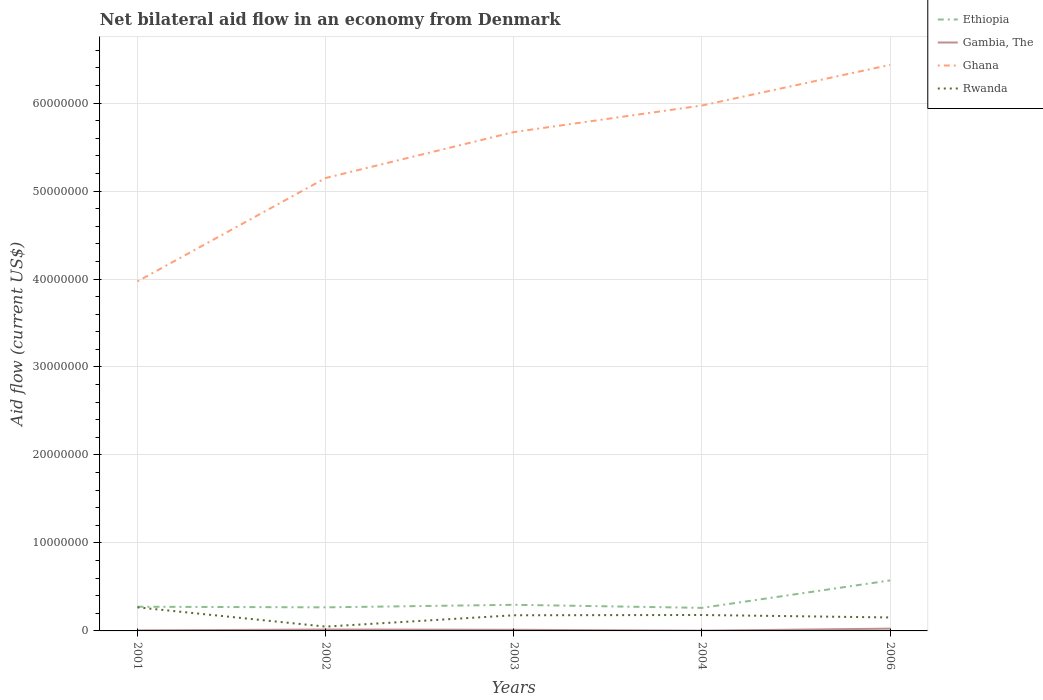Is the number of lines equal to the number of legend labels?
Offer a terse response. Yes. What is the total net bilateral aid flow in Gambia, The in the graph?
Provide a short and direct response. 1.30e+05. What is the difference between the highest and the second highest net bilateral aid flow in Ethiopia?
Offer a terse response. 3.12e+06. How many years are there in the graph?
Give a very brief answer. 5. Are the values on the major ticks of Y-axis written in scientific E-notation?
Offer a terse response. No. Does the graph contain any zero values?
Give a very brief answer. No. How many legend labels are there?
Your response must be concise. 4. What is the title of the graph?
Ensure brevity in your answer.  Net bilateral aid flow in an economy from Denmark. Does "Hong Kong" appear as one of the legend labels in the graph?
Your answer should be very brief. No. What is the label or title of the Y-axis?
Provide a succinct answer. Aid flow (current US$). What is the Aid flow (current US$) of Ethiopia in 2001?
Your response must be concise. 2.75e+06. What is the Aid flow (current US$) in Gambia, The in 2001?
Keep it short and to the point. 6.00e+04. What is the Aid flow (current US$) of Ghana in 2001?
Ensure brevity in your answer.  3.97e+07. What is the Aid flow (current US$) in Rwanda in 2001?
Your answer should be compact. 2.68e+06. What is the Aid flow (current US$) in Ethiopia in 2002?
Give a very brief answer. 2.68e+06. What is the Aid flow (current US$) of Ghana in 2002?
Give a very brief answer. 5.15e+07. What is the Aid flow (current US$) of Ethiopia in 2003?
Provide a short and direct response. 2.97e+06. What is the Aid flow (current US$) of Ghana in 2003?
Give a very brief answer. 5.67e+07. What is the Aid flow (current US$) in Rwanda in 2003?
Your response must be concise. 1.78e+06. What is the Aid flow (current US$) in Ethiopia in 2004?
Provide a short and direct response. 2.62e+06. What is the Aid flow (current US$) of Ghana in 2004?
Offer a very short reply. 5.97e+07. What is the Aid flow (current US$) in Rwanda in 2004?
Give a very brief answer. 1.81e+06. What is the Aid flow (current US$) of Ethiopia in 2006?
Provide a short and direct response. 5.74e+06. What is the Aid flow (current US$) in Gambia, The in 2006?
Make the answer very short. 2.60e+05. What is the Aid flow (current US$) in Ghana in 2006?
Provide a succinct answer. 6.43e+07. What is the Aid flow (current US$) in Rwanda in 2006?
Your answer should be compact. 1.53e+06. Across all years, what is the maximum Aid flow (current US$) in Ethiopia?
Your answer should be very brief. 5.74e+06. Across all years, what is the maximum Aid flow (current US$) in Gambia, The?
Your response must be concise. 2.60e+05. Across all years, what is the maximum Aid flow (current US$) of Ghana?
Keep it short and to the point. 6.43e+07. Across all years, what is the maximum Aid flow (current US$) of Rwanda?
Your answer should be compact. 2.68e+06. Across all years, what is the minimum Aid flow (current US$) in Ethiopia?
Provide a succinct answer. 2.62e+06. Across all years, what is the minimum Aid flow (current US$) of Ghana?
Keep it short and to the point. 3.97e+07. Across all years, what is the minimum Aid flow (current US$) of Rwanda?
Your answer should be compact. 4.90e+05. What is the total Aid flow (current US$) of Ethiopia in the graph?
Your answer should be compact. 1.68e+07. What is the total Aid flow (current US$) in Gambia, The in the graph?
Keep it short and to the point. 6.40e+05. What is the total Aid flow (current US$) in Ghana in the graph?
Keep it short and to the point. 2.72e+08. What is the total Aid flow (current US$) of Rwanda in the graph?
Offer a very short reply. 8.29e+06. What is the difference between the Aid flow (current US$) in Ethiopia in 2001 and that in 2002?
Offer a very short reply. 7.00e+04. What is the difference between the Aid flow (current US$) of Ghana in 2001 and that in 2002?
Your answer should be compact. -1.18e+07. What is the difference between the Aid flow (current US$) of Rwanda in 2001 and that in 2002?
Make the answer very short. 2.19e+06. What is the difference between the Aid flow (current US$) in Ethiopia in 2001 and that in 2003?
Give a very brief answer. -2.20e+05. What is the difference between the Aid flow (current US$) of Gambia, The in 2001 and that in 2003?
Provide a short and direct response. -7.00e+04. What is the difference between the Aid flow (current US$) of Ghana in 2001 and that in 2003?
Your answer should be compact. -1.70e+07. What is the difference between the Aid flow (current US$) in Rwanda in 2001 and that in 2003?
Keep it short and to the point. 9.00e+05. What is the difference between the Aid flow (current US$) in Ethiopia in 2001 and that in 2004?
Your answer should be compact. 1.30e+05. What is the difference between the Aid flow (current US$) in Gambia, The in 2001 and that in 2004?
Your response must be concise. 3.00e+04. What is the difference between the Aid flow (current US$) in Ghana in 2001 and that in 2004?
Offer a terse response. -2.00e+07. What is the difference between the Aid flow (current US$) in Rwanda in 2001 and that in 2004?
Offer a terse response. 8.70e+05. What is the difference between the Aid flow (current US$) of Ethiopia in 2001 and that in 2006?
Provide a short and direct response. -2.99e+06. What is the difference between the Aid flow (current US$) of Gambia, The in 2001 and that in 2006?
Offer a very short reply. -2.00e+05. What is the difference between the Aid flow (current US$) in Ghana in 2001 and that in 2006?
Offer a terse response. -2.46e+07. What is the difference between the Aid flow (current US$) in Rwanda in 2001 and that in 2006?
Ensure brevity in your answer.  1.15e+06. What is the difference between the Aid flow (current US$) of Ethiopia in 2002 and that in 2003?
Your answer should be compact. -2.90e+05. What is the difference between the Aid flow (current US$) in Gambia, The in 2002 and that in 2003?
Your response must be concise. 3.00e+04. What is the difference between the Aid flow (current US$) of Ghana in 2002 and that in 2003?
Make the answer very short. -5.22e+06. What is the difference between the Aid flow (current US$) in Rwanda in 2002 and that in 2003?
Your answer should be compact. -1.29e+06. What is the difference between the Aid flow (current US$) in Ethiopia in 2002 and that in 2004?
Keep it short and to the point. 6.00e+04. What is the difference between the Aid flow (current US$) in Ghana in 2002 and that in 2004?
Offer a very short reply. -8.24e+06. What is the difference between the Aid flow (current US$) of Rwanda in 2002 and that in 2004?
Your answer should be compact. -1.32e+06. What is the difference between the Aid flow (current US$) of Ethiopia in 2002 and that in 2006?
Provide a short and direct response. -3.06e+06. What is the difference between the Aid flow (current US$) in Ghana in 2002 and that in 2006?
Provide a short and direct response. -1.29e+07. What is the difference between the Aid flow (current US$) in Rwanda in 2002 and that in 2006?
Your response must be concise. -1.04e+06. What is the difference between the Aid flow (current US$) of Ethiopia in 2003 and that in 2004?
Your answer should be compact. 3.50e+05. What is the difference between the Aid flow (current US$) in Ghana in 2003 and that in 2004?
Provide a short and direct response. -3.02e+06. What is the difference between the Aid flow (current US$) of Ethiopia in 2003 and that in 2006?
Offer a terse response. -2.77e+06. What is the difference between the Aid flow (current US$) of Ghana in 2003 and that in 2006?
Your answer should be very brief. -7.64e+06. What is the difference between the Aid flow (current US$) in Rwanda in 2003 and that in 2006?
Your response must be concise. 2.50e+05. What is the difference between the Aid flow (current US$) of Ethiopia in 2004 and that in 2006?
Keep it short and to the point. -3.12e+06. What is the difference between the Aid flow (current US$) in Ghana in 2004 and that in 2006?
Give a very brief answer. -4.62e+06. What is the difference between the Aid flow (current US$) of Rwanda in 2004 and that in 2006?
Provide a succinct answer. 2.80e+05. What is the difference between the Aid flow (current US$) in Ethiopia in 2001 and the Aid flow (current US$) in Gambia, The in 2002?
Offer a terse response. 2.59e+06. What is the difference between the Aid flow (current US$) in Ethiopia in 2001 and the Aid flow (current US$) in Ghana in 2002?
Make the answer very short. -4.87e+07. What is the difference between the Aid flow (current US$) in Ethiopia in 2001 and the Aid flow (current US$) in Rwanda in 2002?
Give a very brief answer. 2.26e+06. What is the difference between the Aid flow (current US$) in Gambia, The in 2001 and the Aid flow (current US$) in Ghana in 2002?
Ensure brevity in your answer.  -5.14e+07. What is the difference between the Aid flow (current US$) of Gambia, The in 2001 and the Aid flow (current US$) of Rwanda in 2002?
Make the answer very short. -4.30e+05. What is the difference between the Aid flow (current US$) in Ghana in 2001 and the Aid flow (current US$) in Rwanda in 2002?
Offer a terse response. 3.92e+07. What is the difference between the Aid flow (current US$) of Ethiopia in 2001 and the Aid flow (current US$) of Gambia, The in 2003?
Provide a succinct answer. 2.62e+06. What is the difference between the Aid flow (current US$) of Ethiopia in 2001 and the Aid flow (current US$) of Ghana in 2003?
Ensure brevity in your answer.  -5.40e+07. What is the difference between the Aid flow (current US$) in Ethiopia in 2001 and the Aid flow (current US$) in Rwanda in 2003?
Your response must be concise. 9.70e+05. What is the difference between the Aid flow (current US$) of Gambia, The in 2001 and the Aid flow (current US$) of Ghana in 2003?
Your response must be concise. -5.66e+07. What is the difference between the Aid flow (current US$) of Gambia, The in 2001 and the Aid flow (current US$) of Rwanda in 2003?
Provide a succinct answer. -1.72e+06. What is the difference between the Aid flow (current US$) in Ghana in 2001 and the Aid flow (current US$) in Rwanda in 2003?
Your answer should be compact. 3.80e+07. What is the difference between the Aid flow (current US$) in Ethiopia in 2001 and the Aid flow (current US$) in Gambia, The in 2004?
Ensure brevity in your answer.  2.72e+06. What is the difference between the Aid flow (current US$) of Ethiopia in 2001 and the Aid flow (current US$) of Ghana in 2004?
Give a very brief answer. -5.70e+07. What is the difference between the Aid flow (current US$) in Ethiopia in 2001 and the Aid flow (current US$) in Rwanda in 2004?
Provide a succinct answer. 9.40e+05. What is the difference between the Aid flow (current US$) of Gambia, The in 2001 and the Aid flow (current US$) of Ghana in 2004?
Make the answer very short. -5.97e+07. What is the difference between the Aid flow (current US$) in Gambia, The in 2001 and the Aid flow (current US$) in Rwanda in 2004?
Give a very brief answer. -1.75e+06. What is the difference between the Aid flow (current US$) of Ghana in 2001 and the Aid flow (current US$) of Rwanda in 2004?
Make the answer very short. 3.79e+07. What is the difference between the Aid flow (current US$) in Ethiopia in 2001 and the Aid flow (current US$) in Gambia, The in 2006?
Your answer should be very brief. 2.49e+06. What is the difference between the Aid flow (current US$) in Ethiopia in 2001 and the Aid flow (current US$) in Ghana in 2006?
Make the answer very short. -6.16e+07. What is the difference between the Aid flow (current US$) of Ethiopia in 2001 and the Aid flow (current US$) of Rwanda in 2006?
Your response must be concise. 1.22e+06. What is the difference between the Aid flow (current US$) of Gambia, The in 2001 and the Aid flow (current US$) of Ghana in 2006?
Keep it short and to the point. -6.43e+07. What is the difference between the Aid flow (current US$) of Gambia, The in 2001 and the Aid flow (current US$) of Rwanda in 2006?
Your response must be concise. -1.47e+06. What is the difference between the Aid flow (current US$) in Ghana in 2001 and the Aid flow (current US$) in Rwanda in 2006?
Your response must be concise. 3.82e+07. What is the difference between the Aid flow (current US$) of Ethiopia in 2002 and the Aid flow (current US$) of Gambia, The in 2003?
Offer a very short reply. 2.55e+06. What is the difference between the Aid flow (current US$) of Ethiopia in 2002 and the Aid flow (current US$) of Ghana in 2003?
Give a very brief answer. -5.40e+07. What is the difference between the Aid flow (current US$) of Gambia, The in 2002 and the Aid flow (current US$) of Ghana in 2003?
Your answer should be compact. -5.65e+07. What is the difference between the Aid flow (current US$) in Gambia, The in 2002 and the Aid flow (current US$) in Rwanda in 2003?
Provide a short and direct response. -1.62e+06. What is the difference between the Aid flow (current US$) of Ghana in 2002 and the Aid flow (current US$) of Rwanda in 2003?
Offer a terse response. 4.97e+07. What is the difference between the Aid flow (current US$) in Ethiopia in 2002 and the Aid flow (current US$) in Gambia, The in 2004?
Your answer should be compact. 2.65e+06. What is the difference between the Aid flow (current US$) of Ethiopia in 2002 and the Aid flow (current US$) of Ghana in 2004?
Your answer should be compact. -5.70e+07. What is the difference between the Aid flow (current US$) in Ethiopia in 2002 and the Aid flow (current US$) in Rwanda in 2004?
Make the answer very short. 8.70e+05. What is the difference between the Aid flow (current US$) in Gambia, The in 2002 and the Aid flow (current US$) in Ghana in 2004?
Provide a short and direct response. -5.96e+07. What is the difference between the Aid flow (current US$) in Gambia, The in 2002 and the Aid flow (current US$) in Rwanda in 2004?
Your answer should be very brief. -1.65e+06. What is the difference between the Aid flow (current US$) of Ghana in 2002 and the Aid flow (current US$) of Rwanda in 2004?
Ensure brevity in your answer.  4.97e+07. What is the difference between the Aid flow (current US$) in Ethiopia in 2002 and the Aid flow (current US$) in Gambia, The in 2006?
Provide a short and direct response. 2.42e+06. What is the difference between the Aid flow (current US$) of Ethiopia in 2002 and the Aid flow (current US$) of Ghana in 2006?
Provide a short and direct response. -6.17e+07. What is the difference between the Aid flow (current US$) of Ethiopia in 2002 and the Aid flow (current US$) of Rwanda in 2006?
Your response must be concise. 1.15e+06. What is the difference between the Aid flow (current US$) of Gambia, The in 2002 and the Aid flow (current US$) of Ghana in 2006?
Make the answer very short. -6.42e+07. What is the difference between the Aid flow (current US$) in Gambia, The in 2002 and the Aid flow (current US$) in Rwanda in 2006?
Give a very brief answer. -1.37e+06. What is the difference between the Aid flow (current US$) in Ghana in 2002 and the Aid flow (current US$) in Rwanda in 2006?
Your answer should be very brief. 5.00e+07. What is the difference between the Aid flow (current US$) in Ethiopia in 2003 and the Aid flow (current US$) in Gambia, The in 2004?
Offer a very short reply. 2.94e+06. What is the difference between the Aid flow (current US$) in Ethiopia in 2003 and the Aid flow (current US$) in Ghana in 2004?
Make the answer very short. -5.68e+07. What is the difference between the Aid flow (current US$) of Ethiopia in 2003 and the Aid flow (current US$) of Rwanda in 2004?
Your answer should be compact. 1.16e+06. What is the difference between the Aid flow (current US$) in Gambia, The in 2003 and the Aid flow (current US$) in Ghana in 2004?
Your response must be concise. -5.96e+07. What is the difference between the Aid flow (current US$) of Gambia, The in 2003 and the Aid flow (current US$) of Rwanda in 2004?
Provide a short and direct response. -1.68e+06. What is the difference between the Aid flow (current US$) in Ghana in 2003 and the Aid flow (current US$) in Rwanda in 2004?
Your response must be concise. 5.49e+07. What is the difference between the Aid flow (current US$) of Ethiopia in 2003 and the Aid flow (current US$) of Gambia, The in 2006?
Give a very brief answer. 2.71e+06. What is the difference between the Aid flow (current US$) in Ethiopia in 2003 and the Aid flow (current US$) in Ghana in 2006?
Offer a terse response. -6.14e+07. What is the difference between the Aid flow (current US$) in Ethiopia in 2003 and the Aid flow (current US$) in Rwanda in 2006?
Your answer should be compact. 1.44e+06. What is the difference between the Aid flow (current US$) in Gambia, The in 2003 and the Aid flow (current US$) in Ghana in 2006?
Offer a terse response. -6.42e+07. What is the difference between the Aid flow (current US$) in Gambia, The in 2003 and the Aid flow (current US$) in Rwanda in 2006?
Your answer should be very brief. -1.40e+06. What is the difference between the Aid flow (current US$) in Ghana in 2003 and the Aid flow (current US$) in Rwanda in 2006?
Your answer should be very brief. 5.52e+07. What is the difference between the Aid flow (current US$) of Ethiopia in 2004 and the Aid flow (current US$) of Gambia, The in 2006?
Your answer should be compact. 2.36e+06. What is the difference between the Aid flow (current US$) of Ethiopia in 2004 and the Aid flow (current US$) of Ghana in 2006?
Offer a very short reply. -6.17e+07. What is the difference between the Aid flow (current US$) in Ethiopia in 2004 and the Aid flow (current US$) in Rwanda in 2006?
Give a very brief answer. 1.09e+06. What is the difference between the Aid flow (current US$) in Gambia, The in 2004 and the Aid flow (current US$) in Ghana in 2006?
Give a very brief answer. -6.43e+07. What is the difference between the Aid flow (current US$) in Gambia, The in 2004 and the Aid flow (current US$) in Rwanda in 2006?
Ensure brevity in your answer.  -1.50e+06. What is the difference between the Aid flow (current US$) of Ghana in 2004 and the Aid flow (current US$) of Rwanda in 2006?
Give a very brief answer. 5.82e+07. What is the average Aid flow (current US$) in Ethiopia per year?
Provide a short and direct response. 3.35e+06. What is the average Aid flow (current US$) of Gambia, The per year?
Give a very brief answer. 1.28e+05. What is the average Aid flow (current US$) in Ghana per year?
Provide a short and direct response. 5.44e+07. What is the average Aid flow (current US$) in Rwanda per year?
Offer a very short reply. 1.66e+06. In the year 2001, what is the difference between the Aid flow (current US$) in Ethiopia and Aid flow (current US$) in Gambia, The?
Offer a terse response. 2.69e+06. In the year 2001, what is the difference between the Aid flow (current US$) in Ethiopia and Aid flow (current US$) in Ghana?
Ensure brevity in your answer.  -3.70e+07. In the year 2001, what is the difference between the Aid flow (current US$) of Gambia, The and Aid flow (current US$) of Ghana?
Ensure brevity in your answer.  -3.97e+07. In the year 2001, what is the difference between the Aid flow (current US$) in Gambia, The and Aid flow (current US$) in Rwanda?
Provide a short and direct response. -2.62e+06. In the year 2001, what is the difference between the Aid flow (current US$) in Ghana and Aid flow (current US$) in Rwanda?
Make the answer very short. 3.70e+07. In the year 2002, what is the difference between the Aid flow (current US$) in Ethiopia and Aid flow (current US$) in Gambia, The?
Provide a succinct answer. 2.52e+06. In the year 2002, what is the difference between the Aid flow (current US$) of Ethiopia and Aid flow (current US$) of Ghana?
Make the answer very short. -4.88e+07. In the year 2002, what is the difference between the Aid flow (current US$) in Ethiopia and Aid flow (current US$) in Rwanda?
Keep it short and to the point. 2.19e+06. In the year 2002, what is the difference between the Aid flow (current US$) of Gambia, The and Aid flow (current US$) of Ghana?
Ensure brevity in your answer.  -5.13e+07. In the year 2002, what is the difference between the Aid flow (current US$) of Gambia, The and Aid flow (current US$) of Rwanda?
Provide a succinct answer. -3.30e+05. In the year 2002, what is the difference between the Aid flow (current US$) of Ghana and Aid flow (current US$) of Rwanda?
Make the answer very short. 5.10e+07. In the year 2003, what is the difference between the Aid flow (current US$) of Ethiopia and Aid flow (current US$) of Gambia, The?
Make the answer very short. 2.84e+06. In the year 2003, what is the difference between the Aid flow (current US$) of Ethiopia and Aid flow (current US$) of Ghana?
Give a very brief answer. -5.37e+07. In the year 2003, what is the difference between the Aid flow (current US$) of Ethiopia and Aid flow (current US$) of Rwanda?
Offer a very short reply. 1.19e+06. In the year 2003, what is the difference between the Aid flow (current US$) in Gambia, The and Aid flow (current US$) in Ghana?
Your answer should be very brief. -5.66e+07. In the year 2003, what is the difference between the Aid flow (current US$) in Gambia, The and Aid flow (current US$) in Rwanda?
Make the answer very short. -1.65e+06. In the year 2003, what is the difference between the Aid flow (current US$) of Ghana and Aid flow (current US$) of Rwanda?
Provide a succinct answer. 5.49e+07. In the year 2004, what is the difference between the Aid flow (current US$) in Ethiopia and Aid flow (current US$) in Gambia, The?
Provide a short and direct response. 2.59e+06. In the year 2004, what is the difference between the Aid flow (current US$) in Ethiopia and Aid flow (current US$) in Ghana?
Offer a terse response. -5.71e+07. In the year 2004, what is the difference between the Aid flow (current US$) in Ethiopia and Aid flow (current US$) in Rwanda?
Make the answer very short. 8.10e+05. In the year 2004, what is the difference between the Aid flow (current US$) in Gambia, The and Aid flow (current US$) in Ghana?
Provide a succinct answer. -5.97e+07. In the year 2004, what is the difference between the Aid flow (current US$) of Gambia, The and Aid flow (current US$) of Rwanda?
Provide a short and direct response. -1.78e+06. In the year 2004, what is the difference between the Aid flow (current US$) in Ghana and Aid flow (current US$) in Rwanda?
Offer a very short reply. 5.79e+07. In the year 2006, what is the difference between the Aid flow (current US$) in Ethiopia and Aid flow (current US$) in Gambia, The?
Your response must be concise. 5.48e+06. In the year 2006, what is the difference between the Aid flow (current US$) of Ethiopia and Aid flow (current US$) of Ghana?
Keep it short and to the point. -5.86e+07. In the year 2006, what is the difference between the Aid flow (current US$) in Ethiopia and Aid flow (current US$) in Rwanda?
Your response must be concise. 4.21e+06. In the year 2006, what is the difference between the Aid flow (current US$) in Gambia, The and Aid flow (current US$) in Ghana?
Offer a terse response. -6.41e+07. In the year 2006, what is the difference between the Aid flow (current US$) of Gambia, The and Aid flow (current US$) of Rwanda?
Provide a succinct answer. -1.27e+06. In the year 2006, what is the difference between the Aid flow (current US$) in Ghana and Aid flow (current US$) in Rwanda?
Your answer should be compact. 6.28e+07. What is the ratio of the Aid flow (current US$) in Ethiopia in 2001 to that in 2002?
Keep it short and to the point. 1.03. What is the ratio of the Aid flow (current US$) in Gambia, The in 2001 to that in 2002?
Keep it short and to the point. 0.38. What is the ratio of the Aid flow (current US$) in Ghana in 2001 to that in 2002?
Offer a terse response. 0.77. What is the ratio of the Aid flow (current US$) in Rwanda in 2001 to that in 2002?
Your answer should be very brief. 5.47. What is the ratio of the Aid flow (current US$) in Ethiopia in 2001 to that in 2003?
Keep it short and to the point. 0.93. What is the ratio of the Aid flow (current US$) of Gambia, The in 2001 to that in 2003?
Your answer should be compact. 0.46. What is the ratio of the Aid flow (current US$) in Ghana in 2001 to that in 2003?
Your response must be concise. 0.7. What is the ratio of the Aid flow (current US$) of Rwanda in 2001 to that in 2003?
Provide a short and direct response. 1.51. What is the ratio of the Aid flow (current US$) in Ethiopia in 2001 to that in 2004?
Make the answer very short. 1.05. What is the ratio of the Aid flow (current US$) of Ghana in 2001 to that in 2004?
Keep it short and to the point. 0.67. What is the ratio of the Aid flow (current US$) in Rwanda in 2001 to that in 2004?
Make the answer very short. 1.48. What is the ratio of the Aid flow (current US$) of Ethiopia in 2001 to that in 2006?
Provide a short and direct response. 0.48. What is the ratio of the Aid flow (current US$) in Gambia, The in 2001 to that in 2006?
Provide a succinct answer. 0.23. What is the ratio of the Aid flow (current US$) of Ghana in 2001 to that in 2006?
Offer a very short reply. 0.62. What is the ratio of the Aid flow (current US$) in Rwanda in 2001 to that in 2006?
Offer a very short reply. 1.75. What is the ratio of the Aid flow (current US$) in Ethiopia in 2002 to that in 2003?
Provide a succinct answer. 0.9. What is the ratio of the Aid flow (current US$) of Gambia, The in 2002 to that in 2003?
Make the answer very short. 1.23. What is the ratio of the Aid flow (current US$) of Ghana in 2002 to that in 2003?
Provide a short and direct response. 0.91. What is the ratio of the Aid flow (current US$) in Rwanda in 2002 to that in 2003?
Make the answer very short. 0.28. What is the ratio of the Aid flow (current US$) of Ethiopia in 2002 to that in 2004?
Your answer should be compact. 1.02. What is the ratio of the Aid flow (current US$) of Gambia, The in 2002 to that in 2004?
Keep it short and to the point. 5.33. What is the ratio of the Aid flow (current US$) in Ghana in 2002 to that in 2004?
Make the answer very short. 0.86. What is the ratio of the Aid flow (current US$) in Rwanda in 2002 to that in 2004?
Give a very brief answer. 0.27. What is the ratio of the Aid flow (current US$) in Ethiopia in 2002 to that in 2006?
Make the answer very short. 0.47. What is the ratio of the Aid flow (current US$) of Gambia, The in 2002 to that in 2006?
Your answer should be compact. 0.62. What is the ratio of the Aid flow (current US$) of Ghana in 2002 to that in 2006?
Your response must be concise. 0.8. What is the ratio of the Aid flow (current US$) in Rwanda in 2002 to that in 2006?
Your answer should be very brief. 0.32. What is the ratio of the Aid flow (current US$) in Ethiopia in 2003 to that in 2004?
Provide a short and direct response. 1.13. What is the ratio of the Aid flow (current US$) in Gambia, The in 2003 to that in 2004?
Your answer should be very brief. 4.33. What is the ratio of the Aid flow (current US$) in Ghana in 2003 to that in 2004?
Give a very brief answer. 0.95. What is the ratio of the Aid flow (current US$) in Rwanda in 2003 to that in 2004?
Keep it short and to the point. 0.98. What is the ratio of the Aid flow (current US$) of Ethiopia in 2003 to that in 2006?
Your answer should be very brief. 0.52. What is the ratio of the Aid flow (current US$) of Ghana in 2003 to that in 2006?
Provide a succinct answer. 0.88. What is the ratio of the Aid flow (current US$) in Rwanda in 2003 to that in 2006?
Keep it short and to the point. 1.16. What is the ratio of the Aid flow (current US$) in Ethiopia in 2004 to that in 2006?
Offer a very short reply. 0.46. What is the ratio of the Aid flow (current US$) in Gambia, The in 2004 to that in 2006?
Give a very brief answer. 0.12. What is the ratio of the Aid flow (current US$) in Ghana in 2004 to that in 2006?
Make the answer very short. 0.93. What is the ratio of the Aid flow (current US$) in Rwanda in 2004 to that in 2006?
Ensure brevity in your answer.  1.18. What is the difference between the highest and the second highest Aid flow (current US$) in Ethiopia?
Provide a succinct answer. 2.77e+06. What is the difference between the highest and the second highest Aid flow (current US$) in Gambia, The?
Give a very brief answer. 1.00e+05. What is the difference between the highest and the second highest Aid flow (current US$) of Ghana?
Provide a short and direct response. 4.62e+06. What is the difference between the highest and the second highest Aid flow (current US$) of Rwanda?
Your response must be concise. 8.70e+05. What is the difference between the highest and the lowest Aid flow (current US$) of Ethiopia?
Your answer should be compact. 3.12e+06. What is the difference between the highest and the lowest Aid flow (current US$) in Gambia, The?
Your answer should be compact. 2.30e+05. What is the difference between the highest and the lowest Aid flow (current US$) in Ghana?
Offer a terse response. 2.46e+07. What is the difference between the highest and the lowest Aid flow (current US$) in Rwanda?
Offer a very short reply. 2.19e+06. 